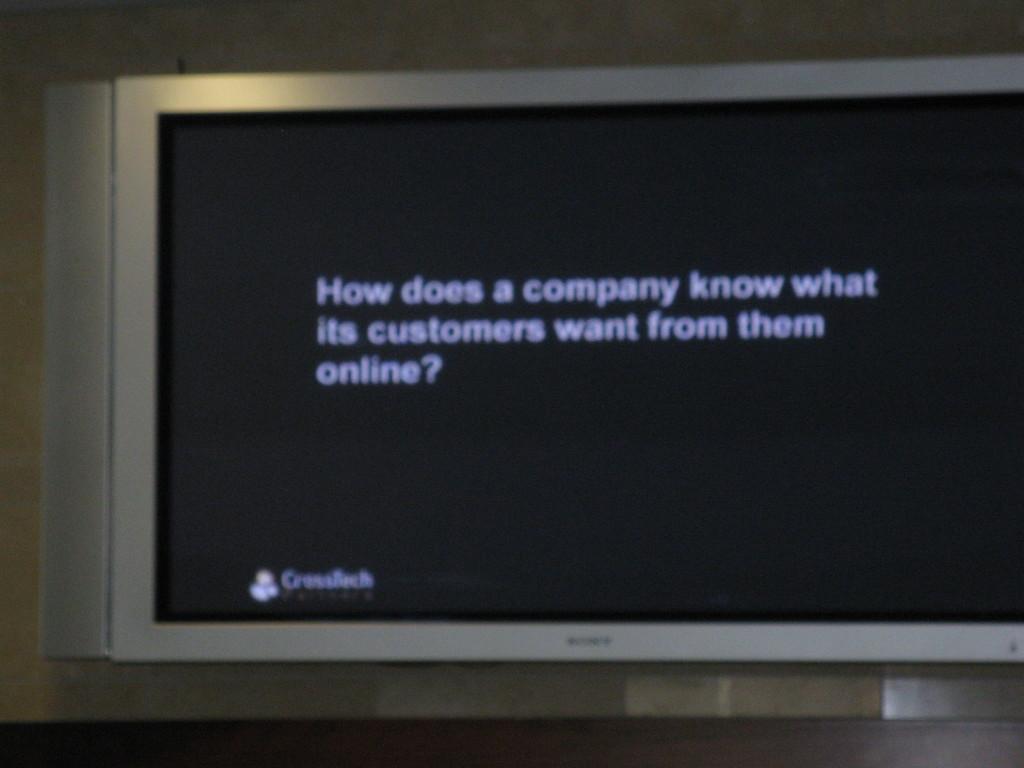Can you be able to read what is on the screen?
Offer a terse response. Yes. Is the question on the screen asking about what customers want online?
Your response must be concise. Yes. 